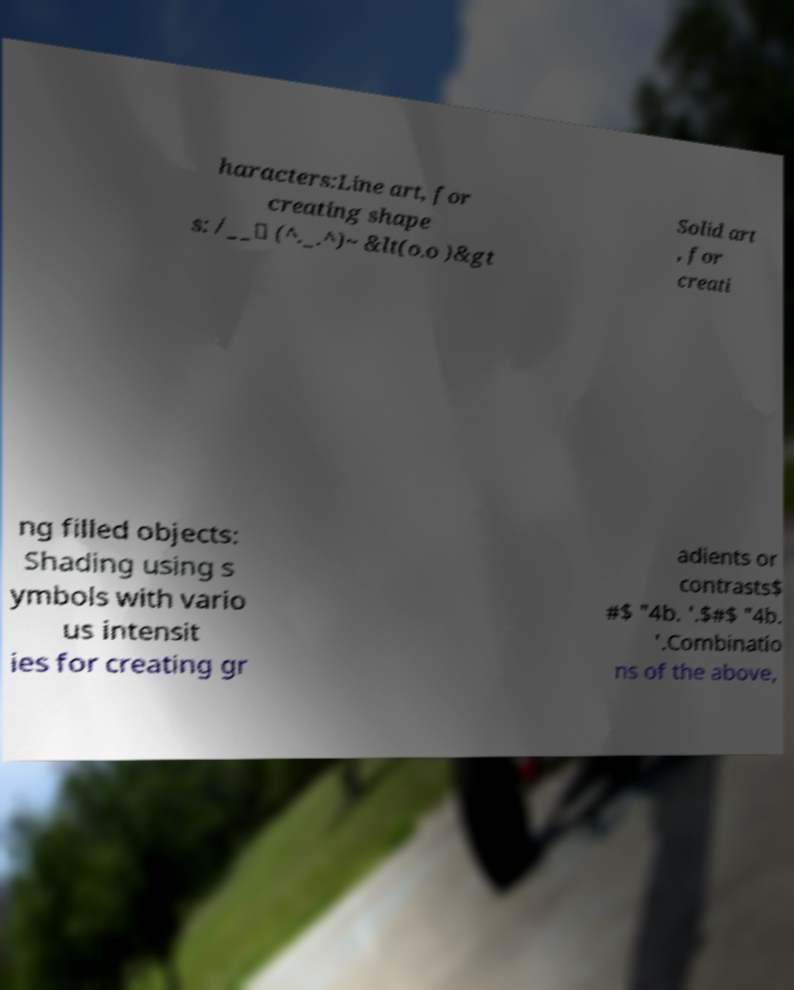Please identify and transcribe the text found in this image. haracters:Line art, for creating shape s: /__\ (^._.^)~ &lt(o.o )&gt Solid art , for creati ng filled objects: Shading using s ymbols with vario us intensit ies for creating gr adients or contrasts$ #$ "4b. '.$#$ "4b. '.Combinatio ns of the above, 